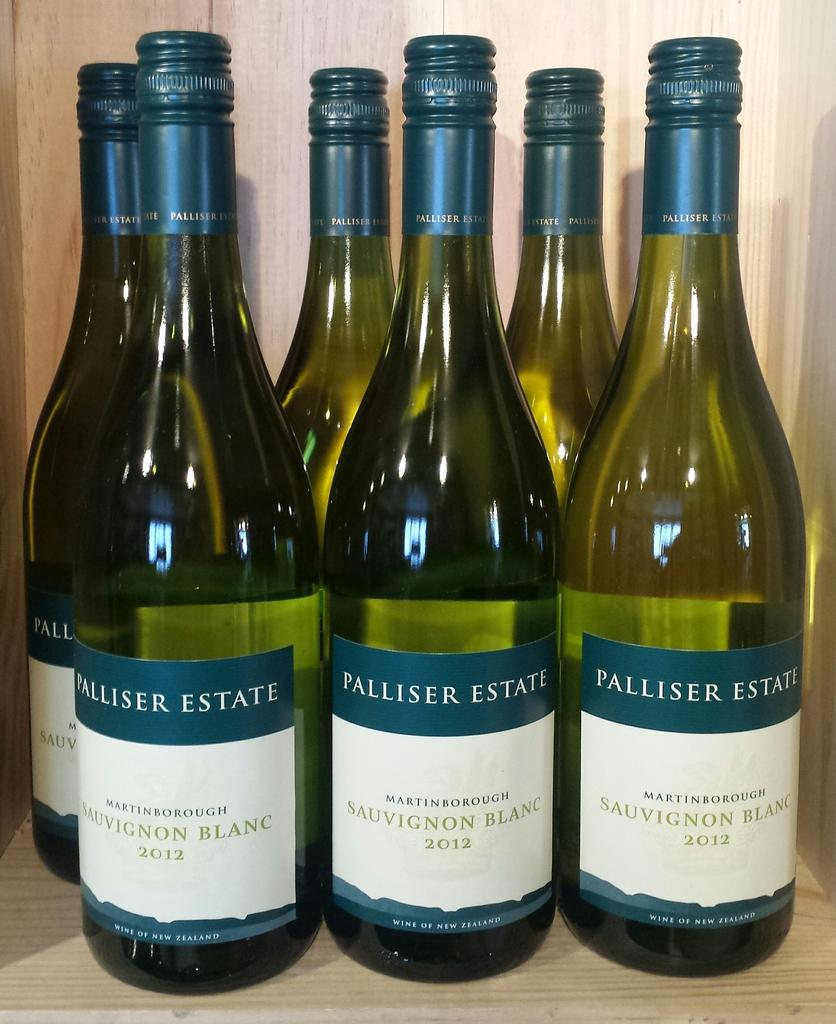<image>
Give a short and clear explanation of the subsequent image. A row of Palliser Estate wine sits on a display 